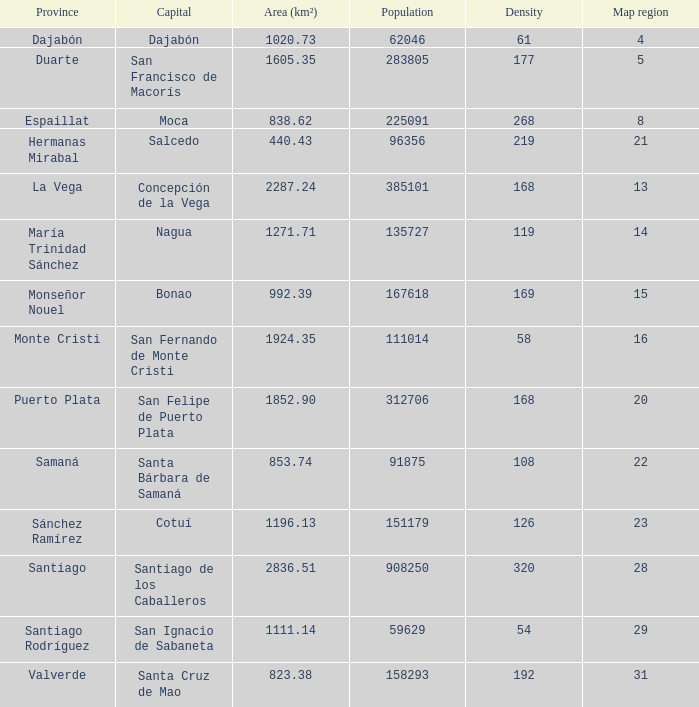Can you provide the area (km²) of nagua? 1271.71. 